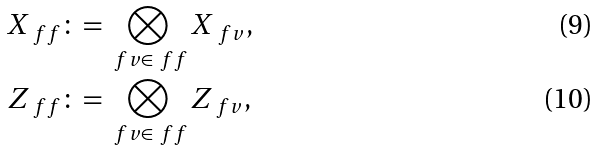<formula> <loc_0><loc_0><loc_500><loc_500>X _ { \ f f } & \colon = \bigotimes _ { \ f v \in \ f f } X _ { \ f v } , \\ Z _ { \ f f } & \colon = \bigotimes _ { \ f v \in \ f f } Z _ { \ f v } ,</formula> 